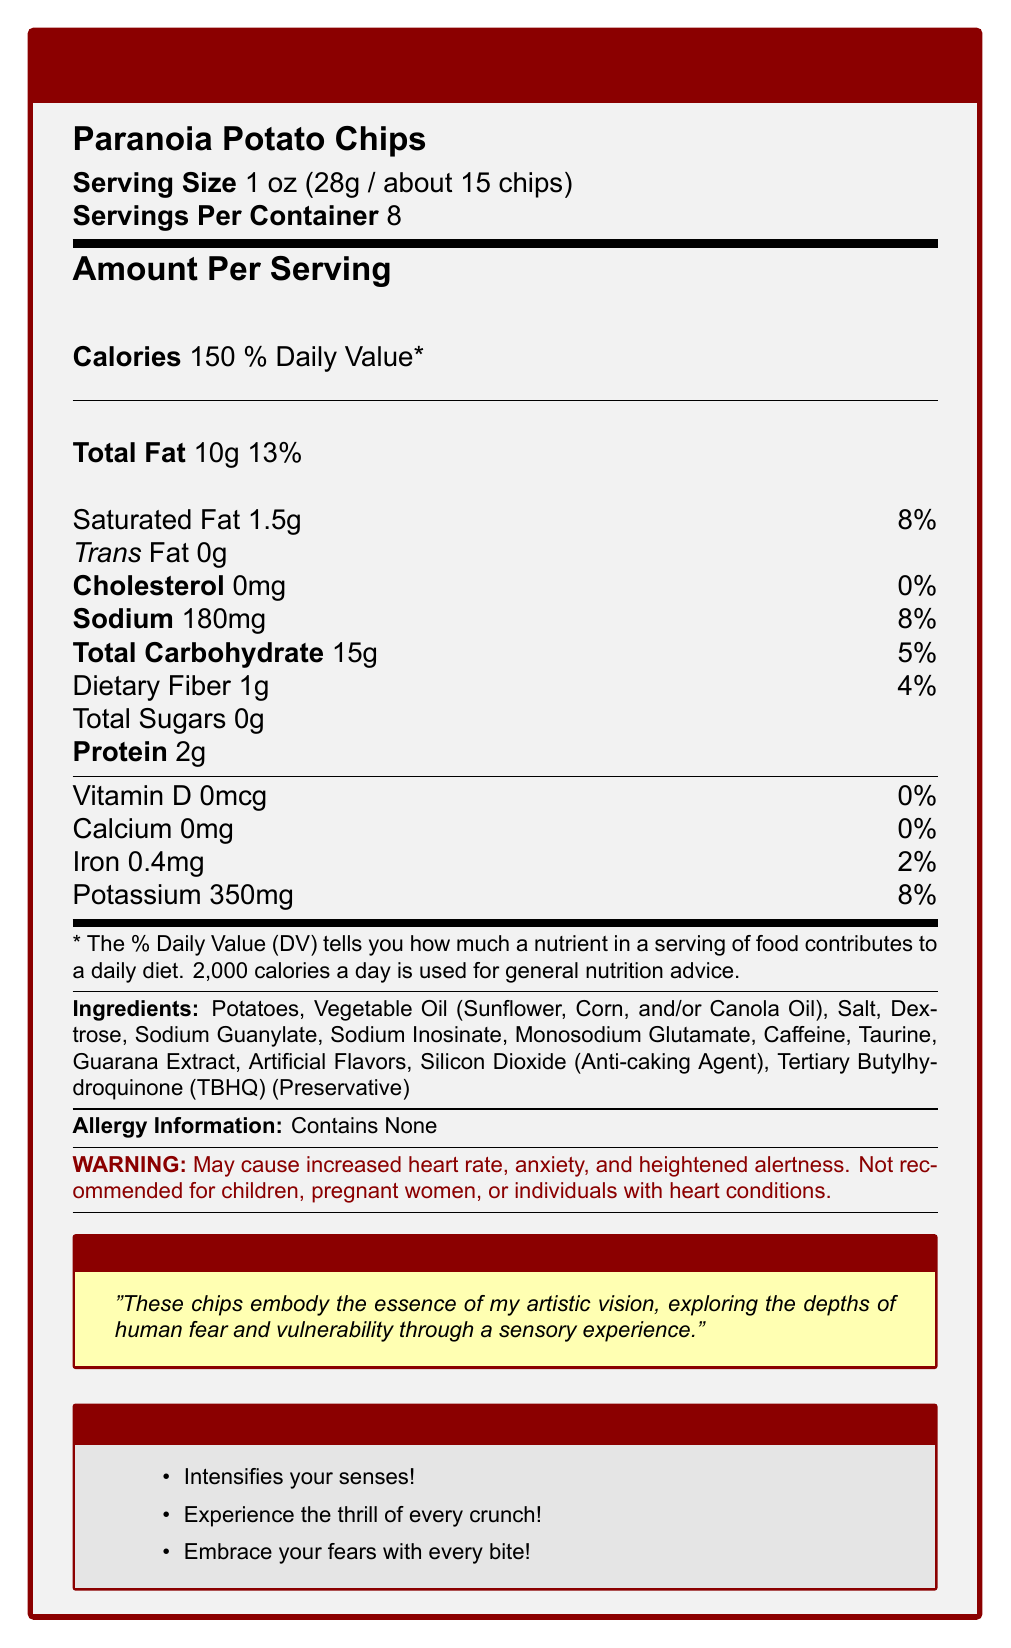what is the serving size for Paranoia Potato Chips? The serving size is stated clearly at the beginning of the document under the product name.
Answer: 1 oz (28g / about 15 chips) how many calories are in one serving of Paranoia Potato Chips? The number of calories per serving is listed under the title "Amount Per Serving".
Answer: 150 how much sodium is in one serving? The amount of sodium per serving is specified in the nutrition facts section.
Answer: 180mg what preservatives are included in the ingredients? The preservative is listed among the ingredients.
Answer: Tertiary Butylhydroquinone (TBHQ) which demographic groups are advised against consuming this product? The warning section explicitly mentions these groups.
Answer: children, pregnant women, individuals with heart conditions how many servings are in a container? The document states "Servings Per Container" as 8.
Answer: 8 how much iron is in a serving of these chips? The amount of iron per serving is listed in the nutrition facts section.
Answer: 0.4mg which one of the marketing claims is NOT mentioned in the document?
A. Embrace your fears with every bite!
B. Experience the thrill of every crunch!
C. Shake your senses with every nibble! The document contains the other two claims, but not the third one.
Answer: C what is the percentage of the daily value of total fat in one serving? A. 8% B. 10% C. 13% D. 15% The daily value percentage of total fat per serving is listed as 13%.
Answer: C does the product contain any cholesterol? The nutrition facts show that the product contains 0mg of cholesterol.
Answer: No summarize the warning for consuming Paranoia Potato Chips. The warning statement provided in the document gives detailed information on potential side effects and advises against consumption by certain groups.
Answer: May cause increased heart rate, anxiety, and heightened alertness. Not recommended for children, pregnant women, or individuals with heart conditions. describe the main idea of the artist’s statement. The artist’s statement explains that the chips are designed to evoke feelings of fear and vulnerability, aligning with the artist’s overall thematic exploration.
Answer: These chips embody the essence of artistic vision, exploring the depths of human fear and vulnerability through a sensory experience. how many grams of dietary fiber are in one serving? The amount of dietary fiber per serving is listed in the nutrition facts.
Answer: 1g which vitamins or minerals are present at 0% daily value in a serving? The document states that both Vitamin D and Calcium are present at 0% daily value in a serving.
Answer: Vitamin D and Calcium what ingredient in Paranoia Potato Chips is commonly associated with increasing alertness? The ingredients list includes caffeine, which is known to increase alertness.
Answer: Caffeine what kind of oil(s) are used to cook the chips? The specific vegetable oils are mentioned in the ingredients list.
Answer: Sunflower, Corn, and/or Canola Oil is the exact amount of each type of vegetable oil specified in the ingredients list? The document states "Sunflower, Corn, and/or Canola Oil" without specifying the amounts of each type.
Answer: No What potential effects do these chips promise to deliver according to the marketing claims?
A. Enhance physical agility
B. Intensify senses
C. Boost memory
D. Provide relaxation The marketing claims include "Intensifies your senses!", which aligns with option B.
Answer: B does the document provide information about the manufacturing process of the chips? The document does not include any details about the manufacturing process.
Answer: Not enough information how much potassium is in a serving of Paranoia Potato Chips? The amount of potassium per serving is listed in the nutrition facts.
Answer: 350mg 